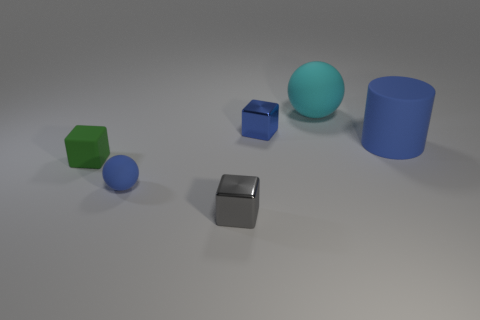Add 1 large cylinders. How many objects exist? 7 Subtract all metallic cubes. How many cubes are left? 1 Subtract all cyan cubes. How many cyan spheres are left? 1 Subtract all brown rubber cylinders. Subtract all tiny gray cubes. How many objects are left? 5 Add 2 tiny green things. How many tiny green things are left? 3 Add 5 large blue matte cylinders. How many large blue matte cylinders exist? 6 Subtract all gray cubes. How many cubes are left? 2 Subtract 1 blue spheres. How many objects are left? 5 Subtract all cylinders. How many objects are left? 5 Subtract 1 cubes. How many cubes are left? 2 